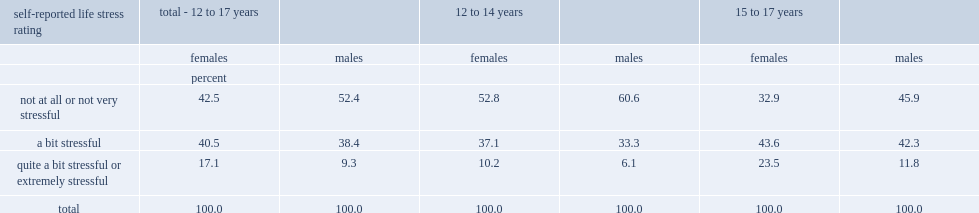Which gender aged 12 to 17 was more likely to report high levels of daily stress? Females. What percentage of girls aged 12 to 17 reported that, on most days, their lives were "quite a bit stressful" or "extremely stressful? 17.1. What percentage of boys aged 12 to 17 reported that, on most days, their lives were "quite a bit stressful" or "extremely stressful? 9.3. Which age group of both genders was more likely to have reported high levels of daily life stress? 15 to 17 years. What percentage of girls aged 15 to 17 reported that, on most days, their lives were "quite a bit stressful" or "extremely stressful? 23.5. What percentage of boys aged 15 to 17 reported that, on most days, their lives were "quite a bit stressful" or "extremely stressful? 11.8. 